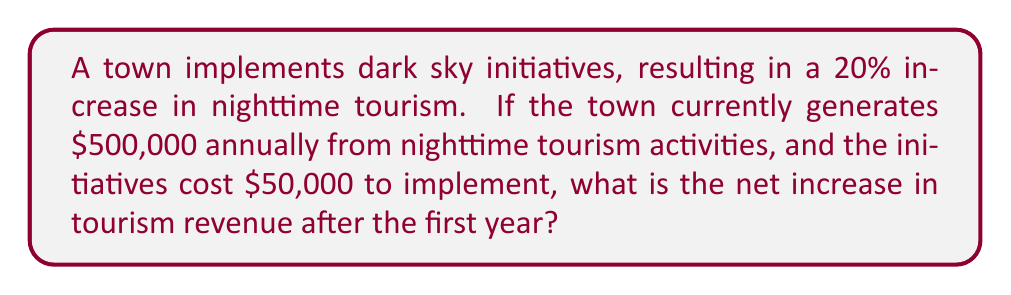Can you solve this math problem? To solve this problem, we'll follow these steps:

1. Calculate the increase in tourism revenue:
   Current revenue: $500,000
   Increase percentage: 20% = 0.20
   Revenue increase: $500,000 * 0.20 = $100,000

2. Calculate the new total revenue:
   New revenue = Current revenue + Revenue increase
   $500,000 + $100,000 = $600,000

3. Calculate the net increase by subtracting the implementation cost:
   Net increase = Revenue increase - Implementation cost
   $100,000 - $50,000 = $50,000

Therefore, the net increase in tourism revenue after the first year is $50,000.

We can express this mathematically as:

$$\text{Net Increase} = (R * i) - C$$

Where:
$R$ = Current revenue
$i$ = Increase percentage (as a decimal)
$C$ = Implementation cost

Plugging in our values:

$$\text{Net Increase} = ($500,000 * 0.20) - $50,000 = $50,000$$
Answer: $50,000 